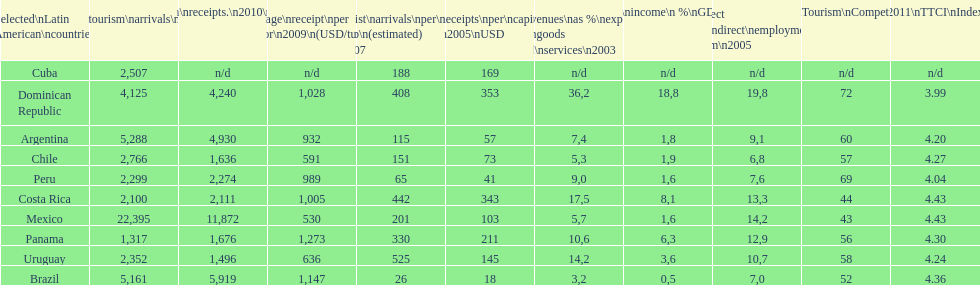Which latin american country had the largest number of tourism arrivals in 2010? Mexico. 